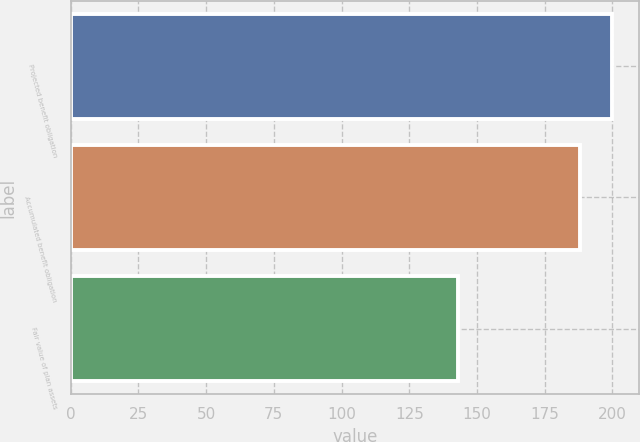<chart> <loc_0><loc_0><loc_500><loc_500><bar_chart><fcel>Projected benefit obligation<fcel>Accumulated benefit obligation<fcel>Fair value of plan assets<nl><fcel>200<fcel>188<fcel>143<nl></chart> 